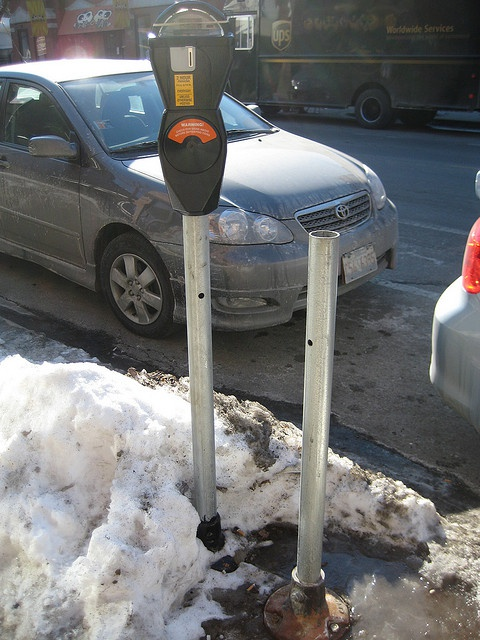Describe the objects in this image and their specific colors. I can see car in gray, black, and white tones, truck in gray, black, and purple tones, parking meter in gray, black, and darkgray tones, and car in gray and white tones in this image. 